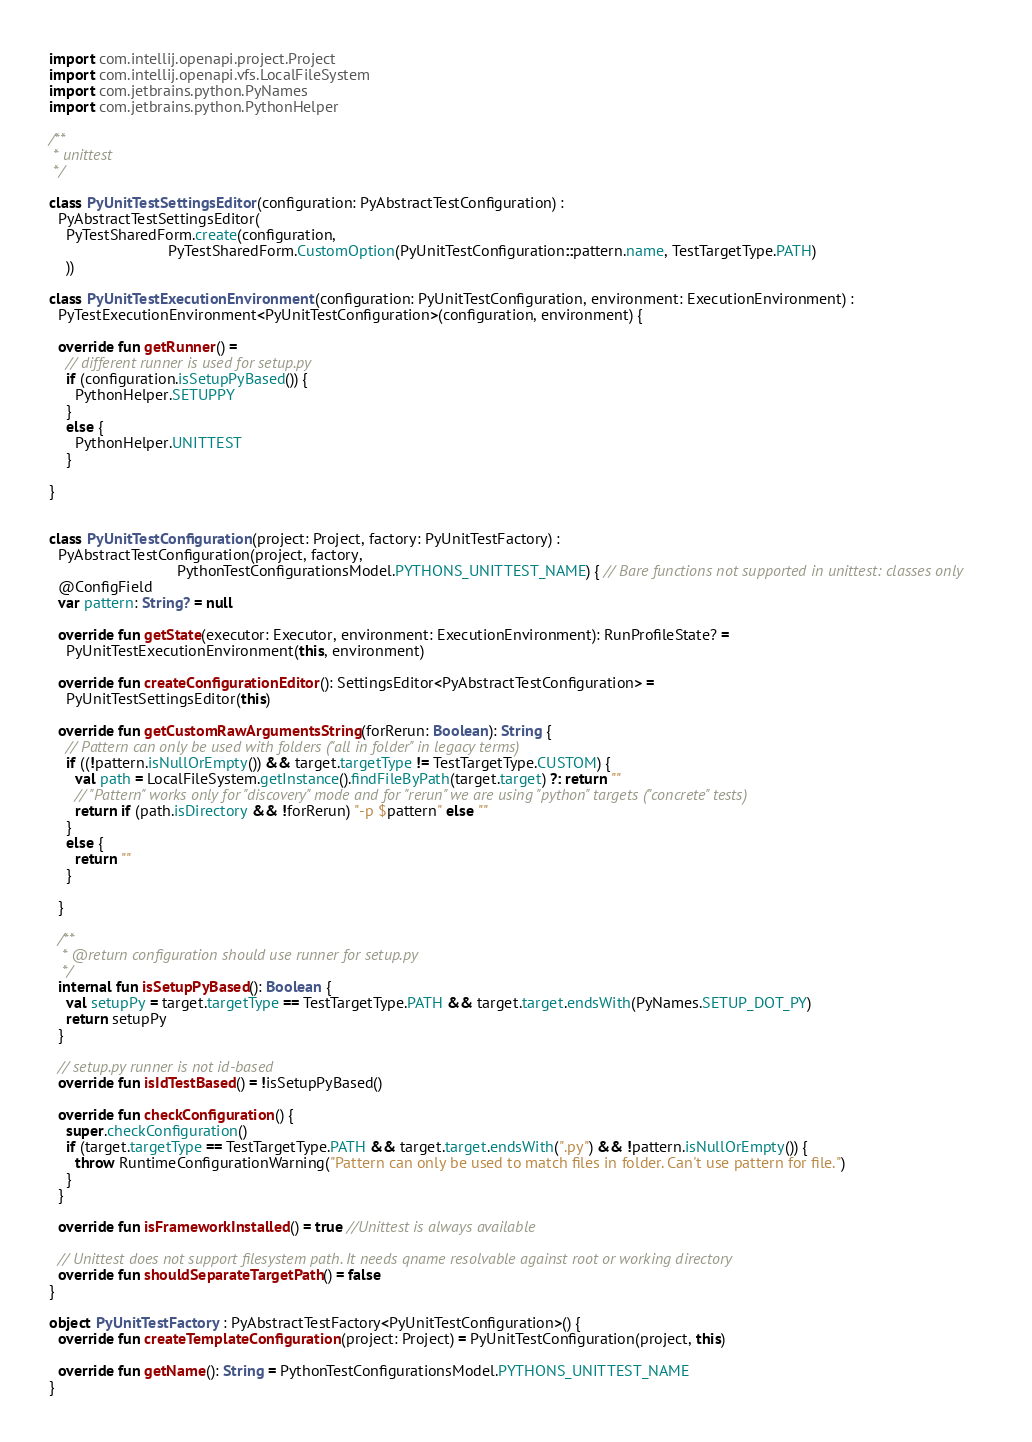<code> <loc_0><loc_0><loc_500><loc_500><_Kotlin_>import com.intellij.openapi.project.Project
import com.intellij.openapi.vfs.LocalFileSystem
import com.jetbrains.python.PyNames
import com.jetbrains.python.PythonHelper

/**
 * unittest
 */

class PyUnitTestSettingsEditor(configuration: PyAbstractTestConfiguration) :
  PyAbstractTestSettingsEditor(
    PyTestSharedForm.create(configuration,
                            PyTestSharedForm.CustomOption(PyUnitTestConfiguration::pattern.name, TestTargetType.PATH)
    ))

class PyUnitTestExecutionEnvironment(configuration: PyUnitTestConfiguration, environment: ExecutionEnvironment) :
  PyTestExecutionEnvironment<PyUnitTestConfiguration>(configuration, environment) {

  override fun getRunner() =
    // different runner is used for setup.py
    if (configuration.isSetupPyBased()) {
      PythonHelper.SETUPPY
    }
    else {
      PythonHelper.UNITTEST
    }

}


class PyUnitTestConfiguration(project: Project, factory: PyUnitTestFactory) :
  PyAbstractTestConfiguration(project, factory,
                              PythonTestConfigurationsModel.PYTHONS_UNITTEST_NAME) { // Bare functions not supported in unittest: classes only
  @ConfigField
  var pattern: String? = null

  override fun getState(executor: Executor, environment: ExecutionEnvironment): RunProfileState? =
    PyUnitTestExecutionEnvironment(this, environment)

  override fun createConfigurationEditor(): SettingsEditor<PyAbstractTestConfiguration> =
    PyUnitTestSettingsEditor(this)

  override fun getCustomRawArgumentsString(forRerun: Boolean): String {
    // Pattern can only be used with folders ("all in folder" in legacy terms)
    if ((!pattern.isNullOrEmpty()) && target.targetType != TestTargetType.CUSTOM) {
      val path = LocalFileSystem.getInstance().findFileByPath(target.target) ?: return ""
      // "Pattern" works only for "discovery" mode and for "rerun" we are using "python" targets ("concrete" tests)
      return if (path.isDirectory && !forRerun) "-p $pattern" else ""
    }
    else {
      return ""
    }

  }

  /**
   * @return configuration should use runner for setup.py
   */
  internal fun isSetupPyBased(): Boolean {
    val setupPy = target.targetType == TestTargetType.PATH && target.target.endsWith(PyNames.SETUP_DOT_PY)
    return setupPy
  }

  // setup.py runner is not id-based
  override fun isIdTestBased() = !isSetupPyBased()

  override fun checkConfiguration() {
    super.checkConfiguration()
    if (target.targetType == TestTargetType.PATH && target.target.endsWith(".py") && !pattern.isNullOrEmpty()) {
      throw RuntimeConfigurationWarning("Pattern can only be used to match files in folder. Can't use pattern for file.")
    }
  }

  override fun isFrameworkInstalled() = true //Unittest is always available

  // Unittest does not support filesystem path. It needs qname resolvable against root or working directory
  override fun shouldSeparateTargetPath() = false
}

object PyUnitTestFactory : PyAbstractTestFactory<PyUnitTestConfiguration>() {
  override fun createTemplateConfiguration(project: Project) = PyUnitTestConfiguration(project, this)

  override fun getName(): String = PythonTestConfigurationsModel.PYTHONS_UNITTEST_NAME
}</code> 